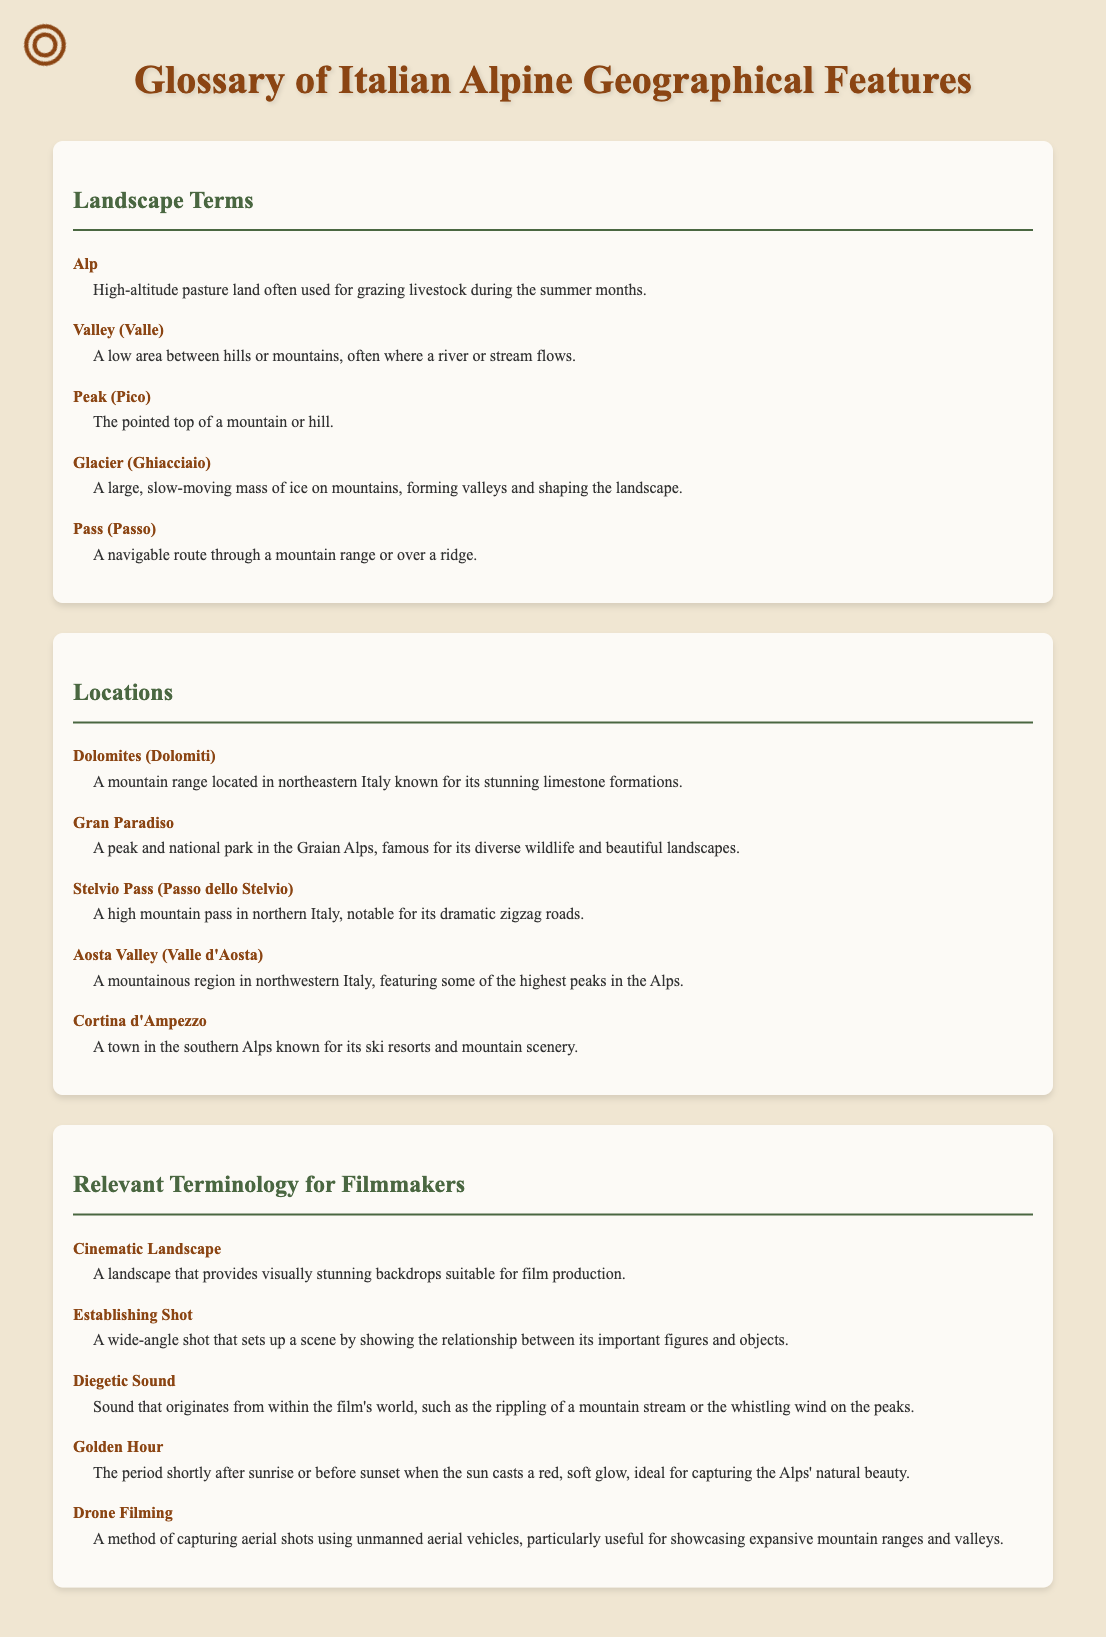What is a high-altitude pasture used for grazing? The term 'Alp' refers to high-altitude pasture land often used for grazing livestock during the summer months.
Answer: Alp What is a navigable route through a mountain range called? The term 'Pass' is used to describe a navigable route through a mountain range or over a ridge.
Answer: Pass Which mountain range is known for its stunning limestone formations? The Dolomites is a mountain range located in northeastern Italy known for its stunning limestone formations.
Answer: Dolomites What is the term for sound that originates from within the film's world? 'Diegetic Sound' refers to sound that originates from within the film's world, such as the rippling of a mountain stream.
Answer: Diegetic Sound What is the name of the peak in the Graian Alps? Gran Paradiso is a peak and national park in the Graian Alps, famous for its diverse wildlife and beautiful landscapes.
Answer: Gran Paradiso What does 'Golden Hour' refer to in filmmaking? The 'Golden Hour' refers to the period shortly after sunrise or before sunset when the sun casts a red, soft glow, ideal for capturing the Alps' natural beauty.
Answer: Golden Hour What is a method of capturing aerial shots using drones? 'Drone Filming' is a method of capturing aerial shots using unmanned aerial vehicles.
Answer: Drone Filming What is a low area between hills or mountains called? The term 'Valley' describes a low area between hills or mountains, often where a river or stream flows.
Answer: Valley What is a large, slow-moving mass of ice on mountains called? 'Glacier' is the term for a large, slow-moving mass of ice on mountains, forming valleys and shaping the landscape.
Answer: Glacier 